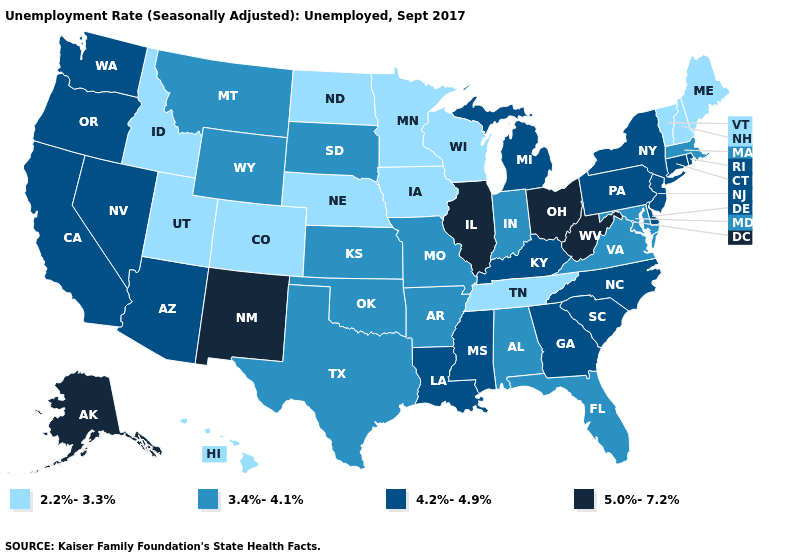What is the highest value in the South ?
Be succinct. 5.0%-7.2%. Name the states that have a value in the range 2.2%-3.3%?
Be succinct. Colorado, Hawaii, Idaho, Iowa, Maine, Minnesota, Nebraska, New Hampshire, North Dakota, Tennessee, Utah, Vermont, Wisconsin. What is the highest value in the USA?
Concise answer only. 5.0%-7.2%. Name the states that have a value in the range 2.2%-3.3%?
Short answer required. Colorado, Hawaii, Idaho, Iowa, Maine, Minnesota, Nebraska, New Hampshire, North Dakota, Tennessee, Utah, Vermont, Wisconsin. Does the map have missing data?
Keep it brief. No. What is the value of Oklahoma?
Concise answer only. 3.4%-4.1%. What is the value of Tennessee?
Give a very brief answer. 2.2%-3.3%. Is the legend a continuous bar?
Keep it brief. No. Which states have the highest value in the USA?
Be succinct. Alaska, Illinois, New Mexico, Ohio, West Virginia. What is the lowest value in the South?
Be succinct. 2.2%-3.3%. What is the value of New Mexico?
Give a very brief answer. 5.0%-7.2%. Name the states that have a value in the range 4.2%-4.9%?
Keep it brief. Arizona, California, Connecticut, Delaware, Georgia, Kentucky, Louisiana, Michigan, Mississippi, Nevada, New Jersey, New York, North Carolina, Oregon, Pennsylvania, Rhode Island, South Carolina, Washington. What is the value of Missouri?
Answer briefly. 3.4%-4.1%. Among the states that border Ohio , does Indiana have the lowest value?
Short answer required. Yes. 